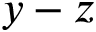Convert formula to latex. <formula><loc_0><loc_0><loc_500><loc_500>y - z</formula> 